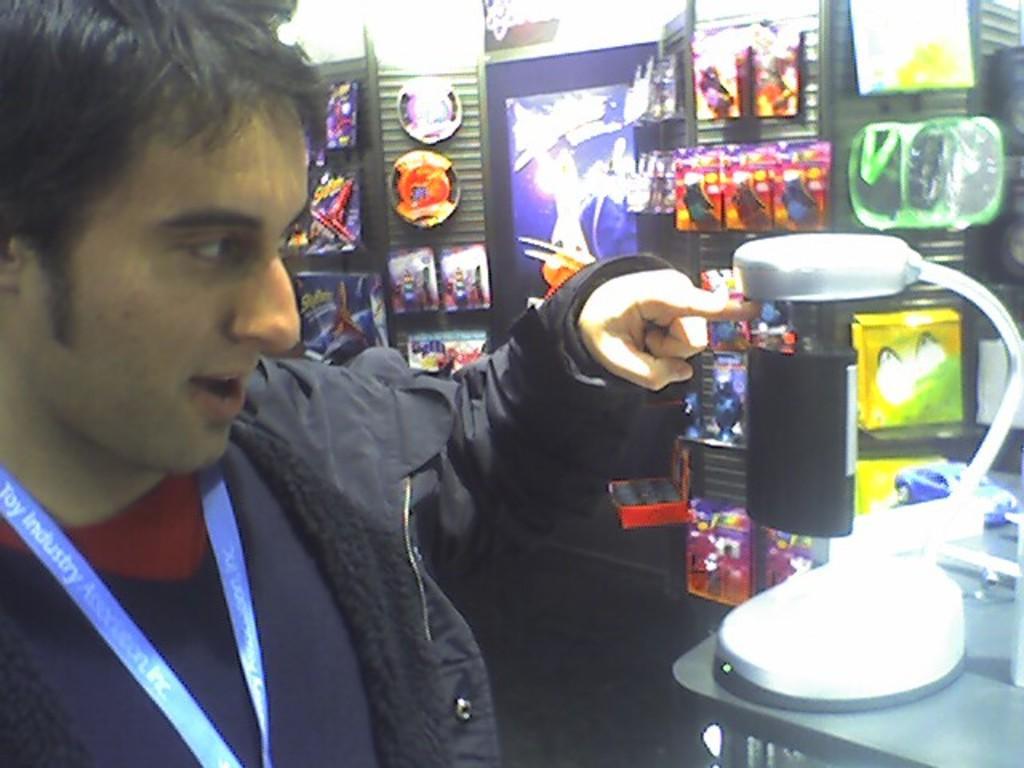Can you describe this image briefly? In the picture I can see a person wearing black jacket is standing in the left corner and there is an object in front of him in the right corner and there are some other objects in the background. 